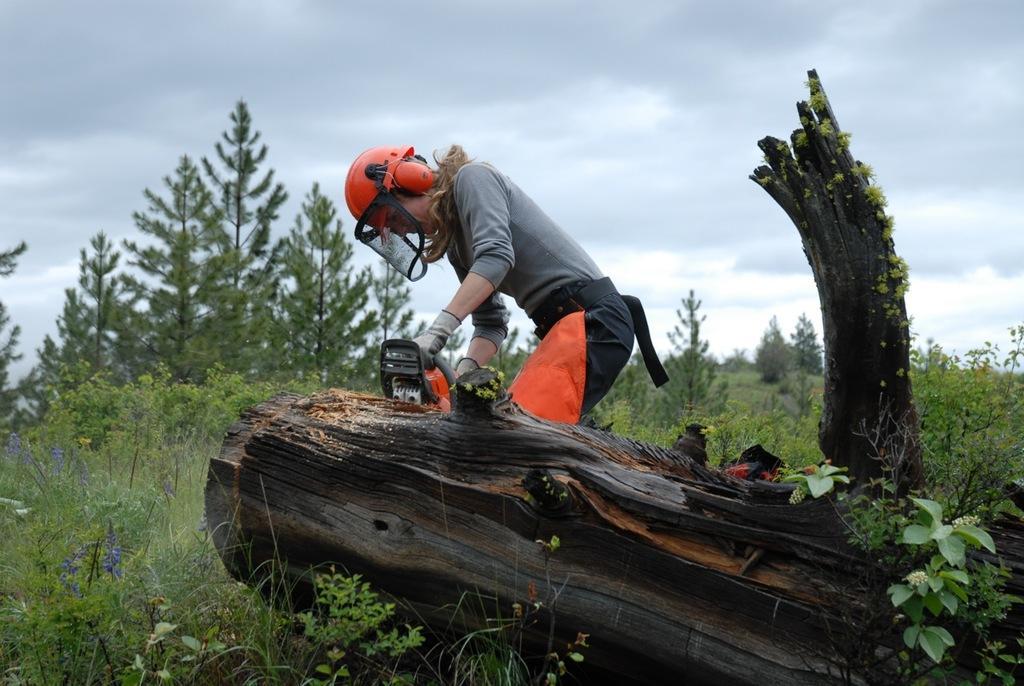Describe this image in one or two sentences. In this picture we can see a person wearing a helmet and holding a machine in her hand. This machine is kept on a wooden object. We can see some grass and plants on the ground. There are a few trees visible in the background. Sky is cloudy. 